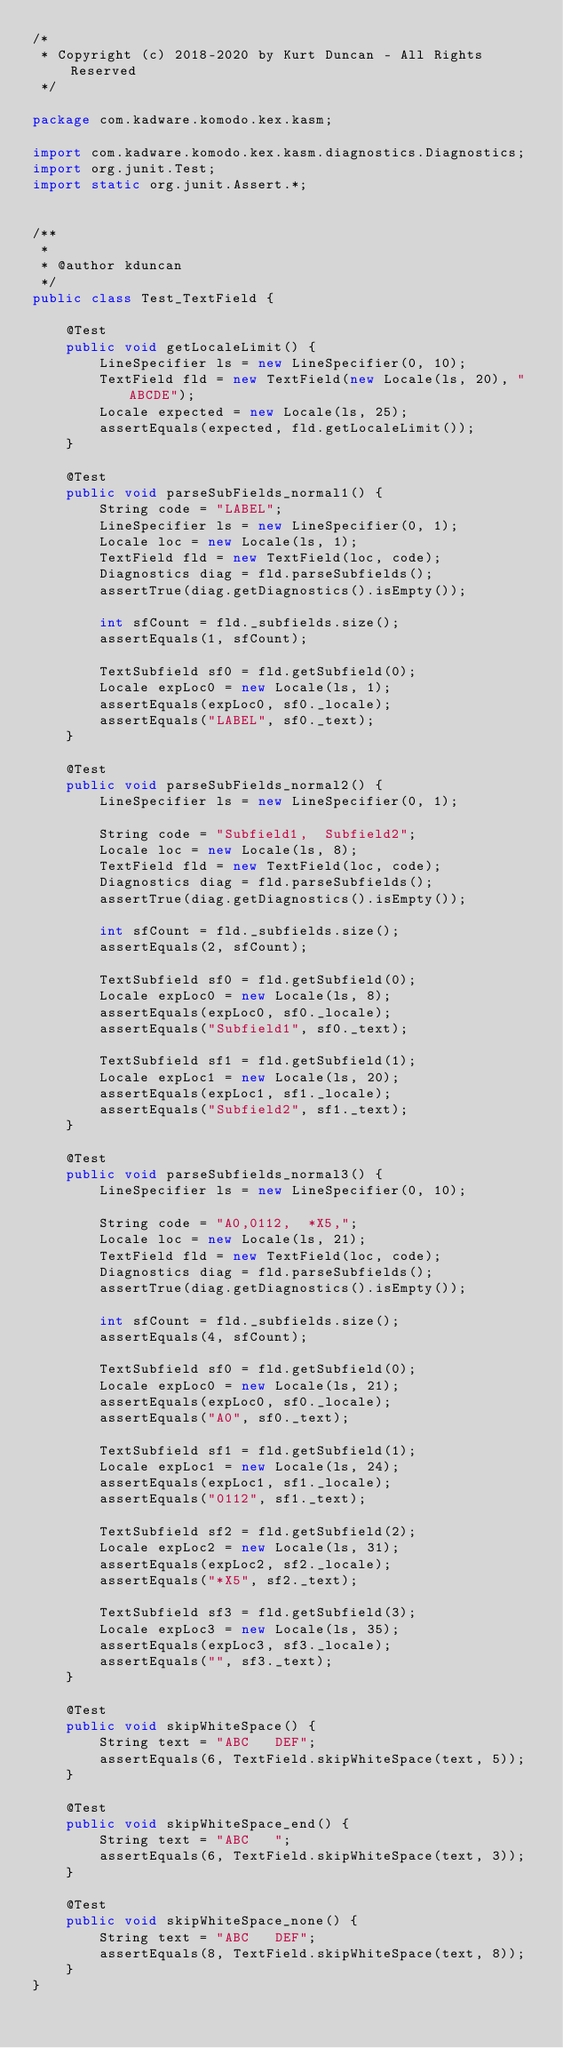<code> <loc_0><loc_0><loc_500><loc_500><_Java_>/*
 * Copyright (c) 2018-2020 by Kurt Duncan - All Rights Reserved
 */

package com.kadware.komodo.kex.kasm;

import com.kadware.komodo.kex.kasm.diagnostics.Diagnostics;
import org.junit.Test;
import static org.junit.Assert.*;


/**
 *
 * @author kduncan
 */
public class Test_TextField {

    @Test
    public void getLocaleLimit() {
        LineSpecifier ls = new LineSpecifier(0, 10);
        TextField fld = new TextField(new Locale(ls, 20), "ABCDE");
        Locale expected = new Locale(ls, 25);
        assertEquals(expected, fld.getLocaleLimit());
    }

    @Test
    public void parseSubFields_normal1() {
        String code = "LABEL";
        LineSpecifier ls = new LineSpecifier(0, 1);
        Locale loc = new Locale(ls, 1);
        TextField fld = new TextField(loc, code);
        Diagnostics diag = fld.parseSubfields();
        assertTrue(diag.getDiagnostics().isEmpty());

        int sfCount = fld._subfields.size();
        assertEquals(1, sfCount);

        TextSubfield sf0 = fld.getSubfield(0);
        Locale expLoc0 = new Locale(ls, 1);
        assertEquals(expLoc0, sf0._locale);
        assertEquals("LABEL", sf0._text);
    }

    @Test
    public void parseSubFields_normal2() {
        LineSpecifier ls = new LineSpecifier(0, 1);

        String code = "Subfield1,  Subfield2";
        Locale loc = new Locale(ls, 8);
        TextField fld = new TextField(loc, code);
        Diagnostics diag = fld.parseSubfields();
        assertTrue(diag.getDiagnostics().isEmpty());

        int sfCount = fld._subfields.size();
        assertEquals(2, sfCount);

        TextSubfield sf0 = fld.getSubfield(0);
        Locale expLoc0 = new Locale(ls, 8);
        assertEquals(expLoc0, sf0._locale);
        assertEquals("Subfield1", sf0._text);

        TextSubfield sf1 = fld.getSubfield(1);
        Locale expLoc1 = new Locale(ls, 20);
        assertEquals(expLoc1, sf1._locale);
        assertEquals("Subfield2", sf1._text);
    }

    @Test
    public void parseSubfields_normal3() {
        LineSpecifier ls = new LineSpecifier(0, 10);

        String code = "A0,0112,  *X5,";
        Locale loc = new Locale(ls, 21);
        TextField fld = new TextField(loc, code);
        Diagnostics diag = fld.parseSubfields();
        assertTrue(diag.getDiagnostics().isEmpty());

        int sfCount = fld._subfields.size();
        assertEquals(4, sfCount);

        TextSubfield sf0 = fld.getSubfield(0);
        Locale expLoc0 = new Locale(ls, 21);
        assertEquals(expLoc0, sf0._locale);
        assertEquals("A0", sf0._text);

        TextSubfield sf1 = fld.getSubfield(1);
        Locale expLoc1 = new Locale(ls, 24);
        assertEquals(expLoc1, sf1._locale);
        assertEquals("0112", sf1._text);

        TextSubfield sf2 = fld.getSubfield(2);
        Locale expLoc2 = new Locale(ls, 31);
        assertEquals(expLoc2, sf2._locale);
        assertEquals("*X5", sf2._text);

        TextSubfield sf3 = fld.getSubfield(3);
        Locale expLoc3 = new Locale(ls, 35);
        assertEquals(expLoc3, sf3._locale);
        assertEquals("", sf3._text);
    }

    @Test
    public void skipWhiteSpace() {
        String text = "ABC   DEF";
        assertEquals(6, TextField.skipWhiteSpace(text, 5));
    }

    @Test
    public void skipWhiteSpace_end() {
        String text = "ABC   ";
        assertEquals(6, TextField.skipWhiteSpace(text, 3));
    }

    @Test
    public void skipWhiteSpace_none() {
        String text = "ABC   DEF";
        assertEquals(8, TextField.skipWhiteSpace(text, 8));
    }
}
</code> 